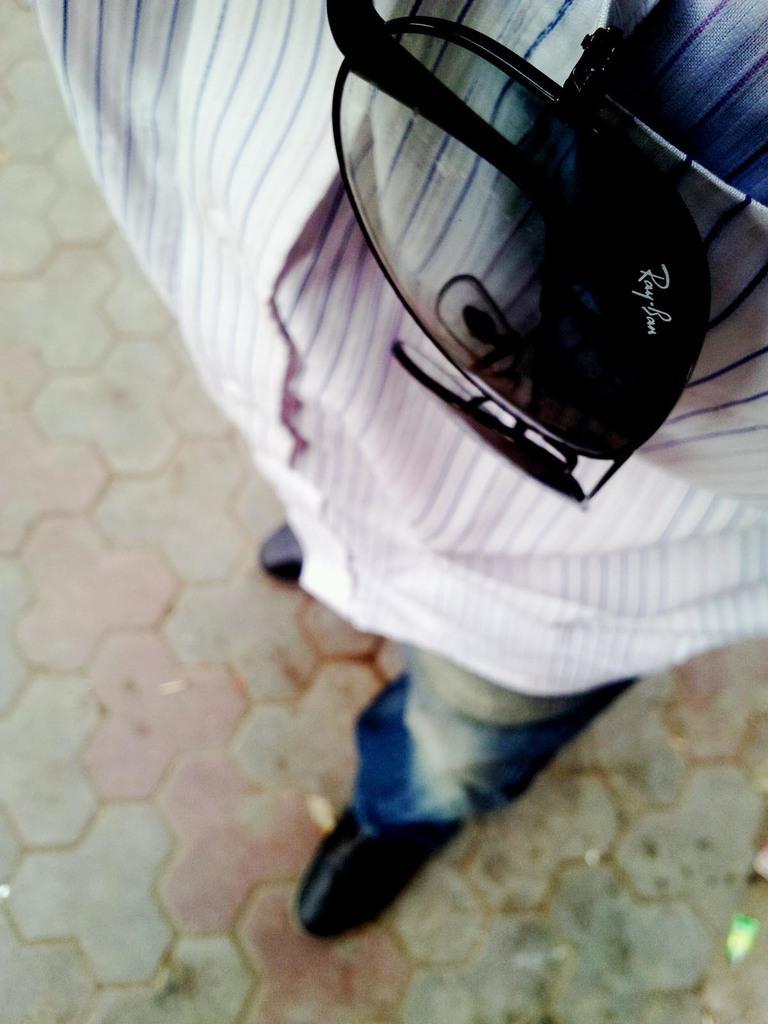Could you give a brief overview of what you see in this image? This picture shows a man and we see sunglasses in the pocket and he wore a black shoes and a blue jeans and a white shirt with Blue lines on it. 